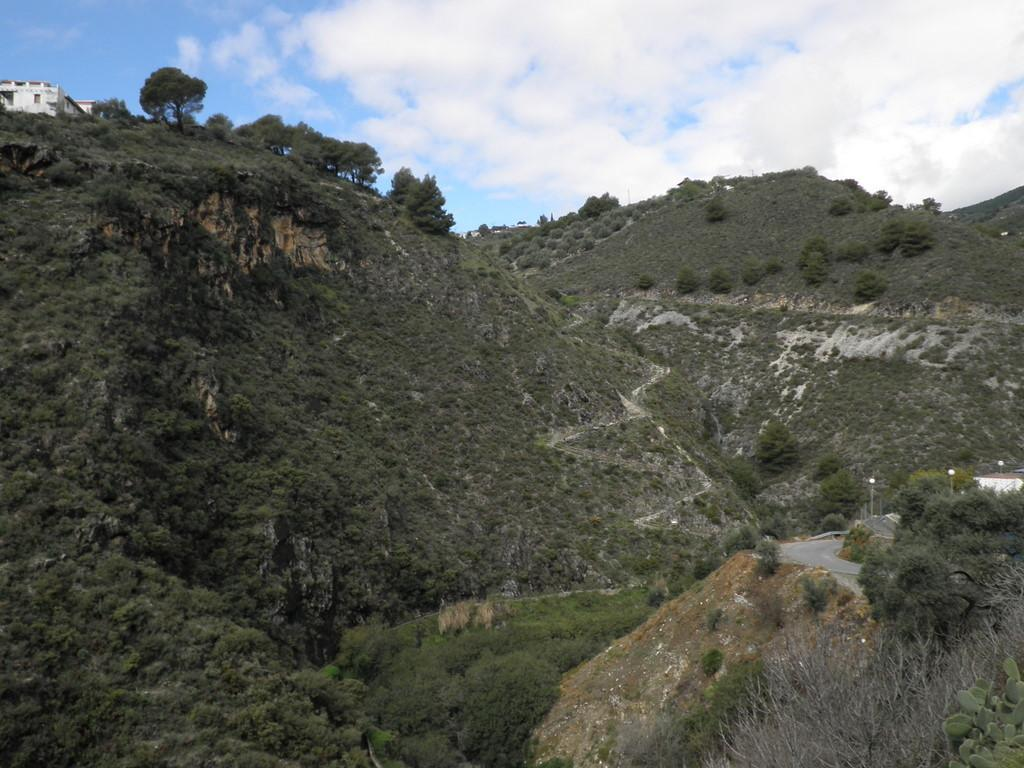What type of natural formation can be seen in the image? There are mountains in the image. What are the mountains made up of? The mountains are made up of trees. What man-made structure is present in the image? There is a road in the image. How many street lights are present along the road? The road includes three street lights. What other features can be seen along the road? The road also has street poles with lights. Can you describe the route visible in the image? The route is visible in the image, winding through the mountains. What month is it in the image? The month cannot be determined from the image, as it does not contain any information about the time of year. Is the queen present in the image? There is no queen present in the image. What type of tree is growing on the side of the road? The image does not specify the type of tree growing on the side of the road, as it only mentions that the mountains are made up of trees. 